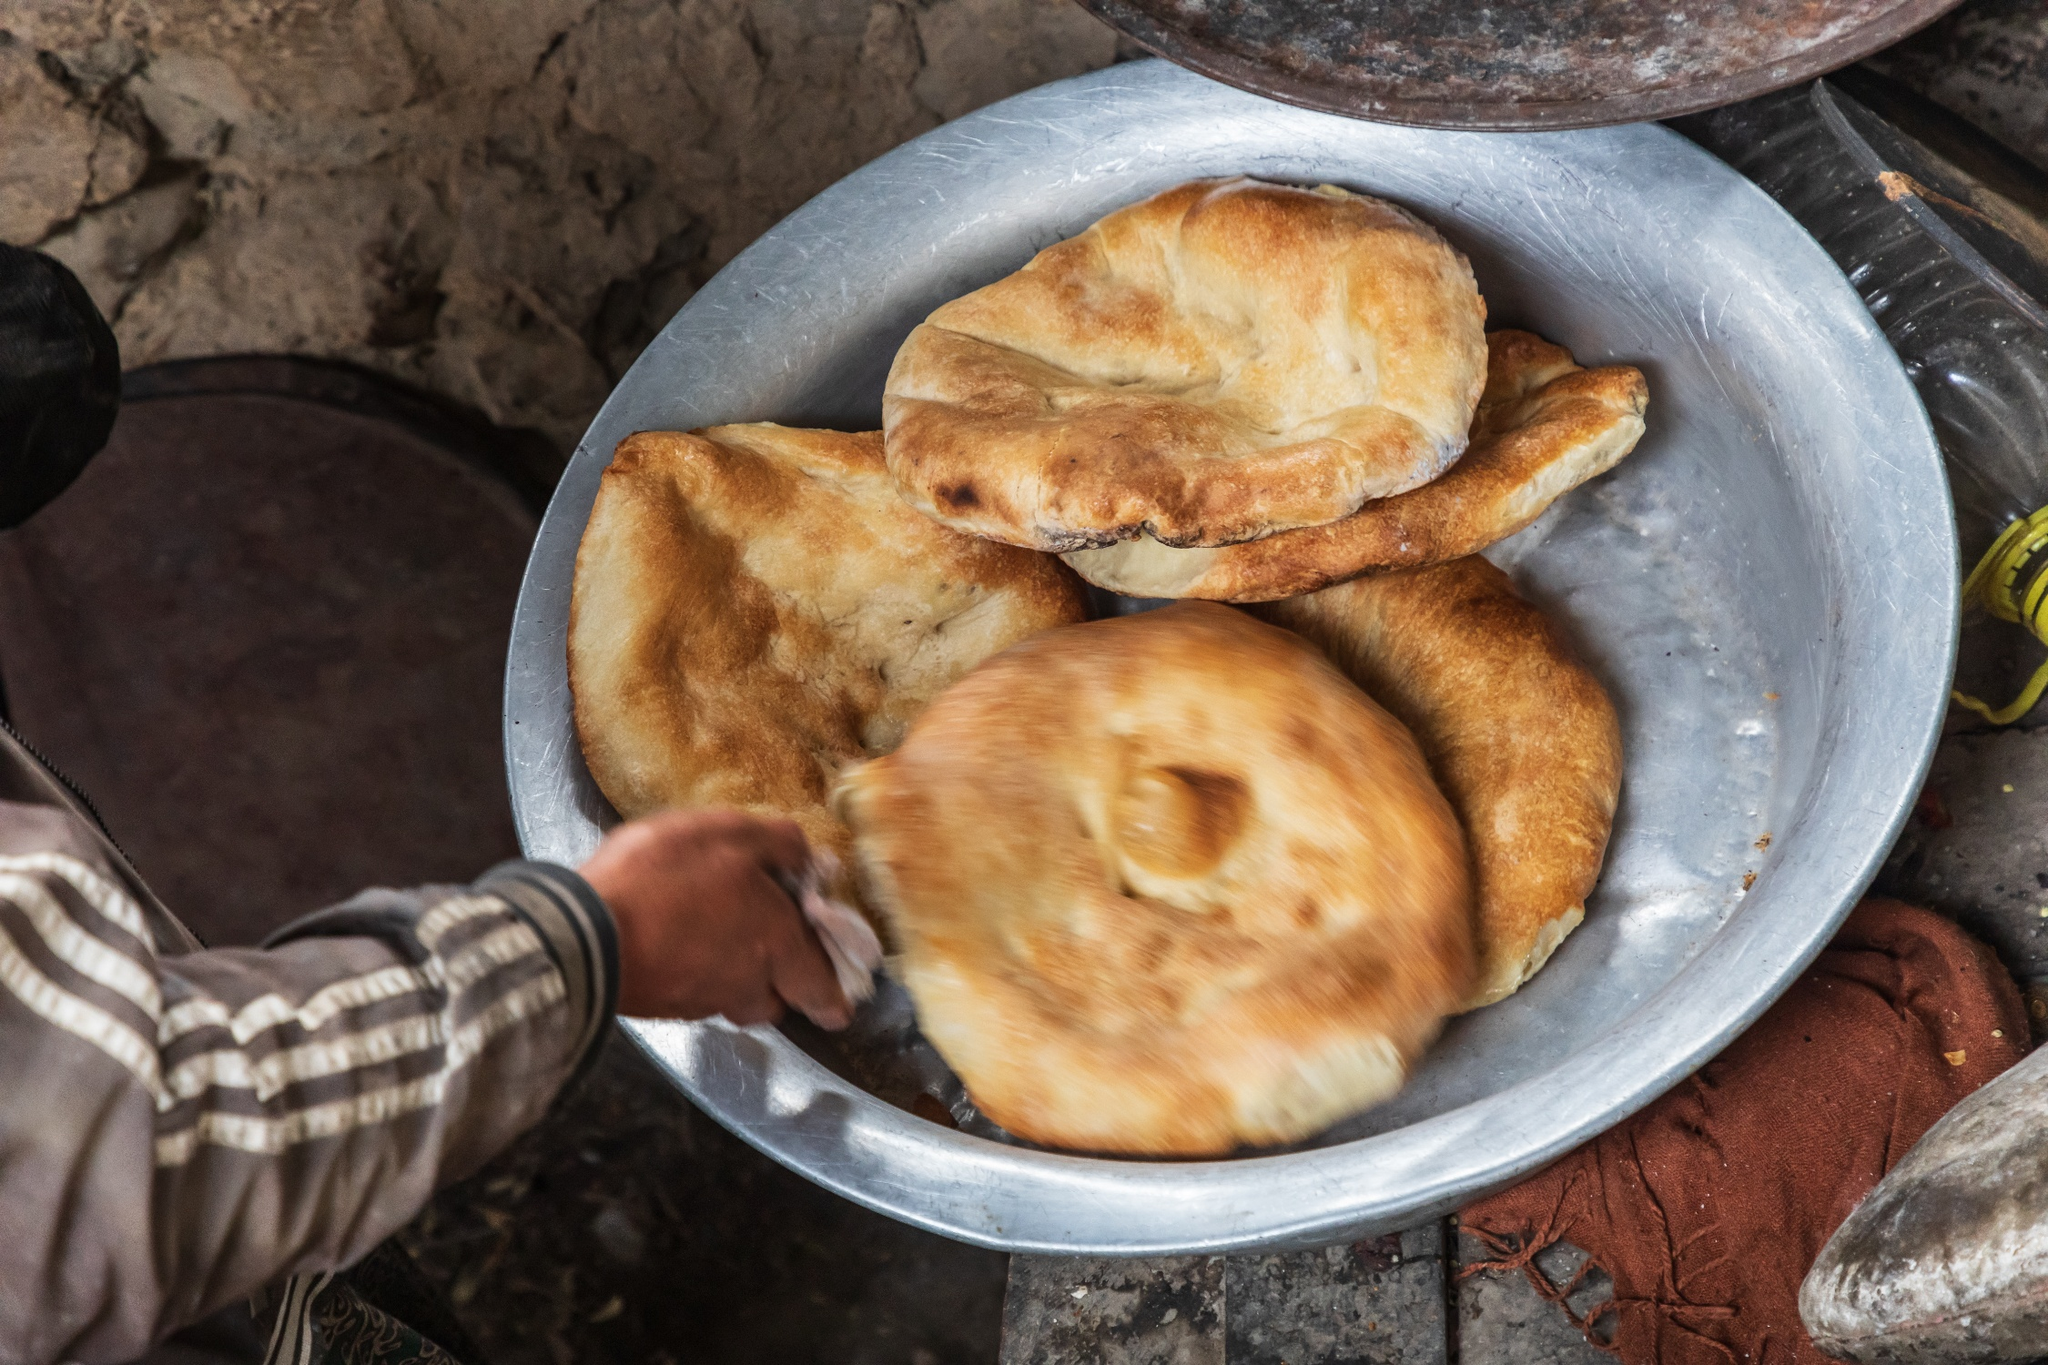Can you describe the main features of this image for me? The image showcases a rustic setting where a person is handling fresh, golden-brown bread placed on a large metal plate. The visible hand, adorned with a striped sleeve, is likely in the process of arranging or serving the bread. The breads appear soft and inviting, with a slightly crispy exterior. Behind the plate, a bottle of oil is partially visible, hinting at food preparation or meal serving. The scene conveys simplicity and a touch of daily life, emphasizing a warm, communal meal. 